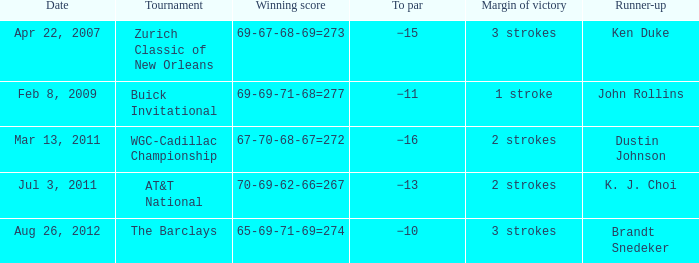Who came in second in the contest that had a victory difference of 2 strokes and a to par of −16? Dustin Johnson. 